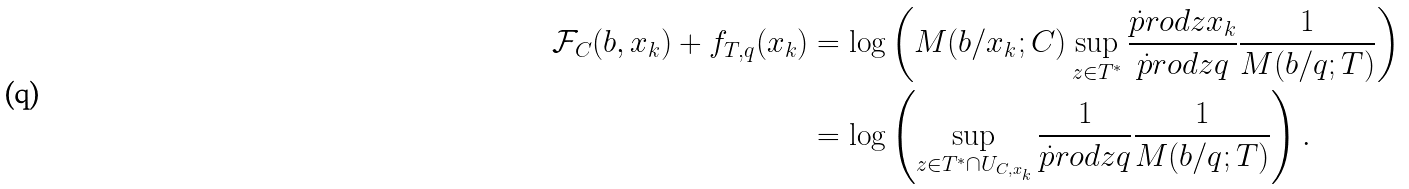<formula> <loc_0><loc_0><loc_500><loc_500>\mathcal { F } _ { C } ( b , x _ { k } ) + f _ { T , q } ( x _ { k } ) & = \log \left ( M ( b / x _ { k } ; C ) \sup _ { z \in T ^ { * } } \frac { \dot { p } r o d { z } { x _ { k } } } { \dot { p } r o d { z } { q } } \frac { 1 } { M ( b / q ; T ) } \right ) \\ & = \log \left ( \sup _ { z \in T ^ { * } \cap U _ { C , x _ { k } } } \frac { 1 } { \dot { p } r o d { z } { q } } \frac { 1 } { M ( b / q ; T ) } \right ) .</formula> 